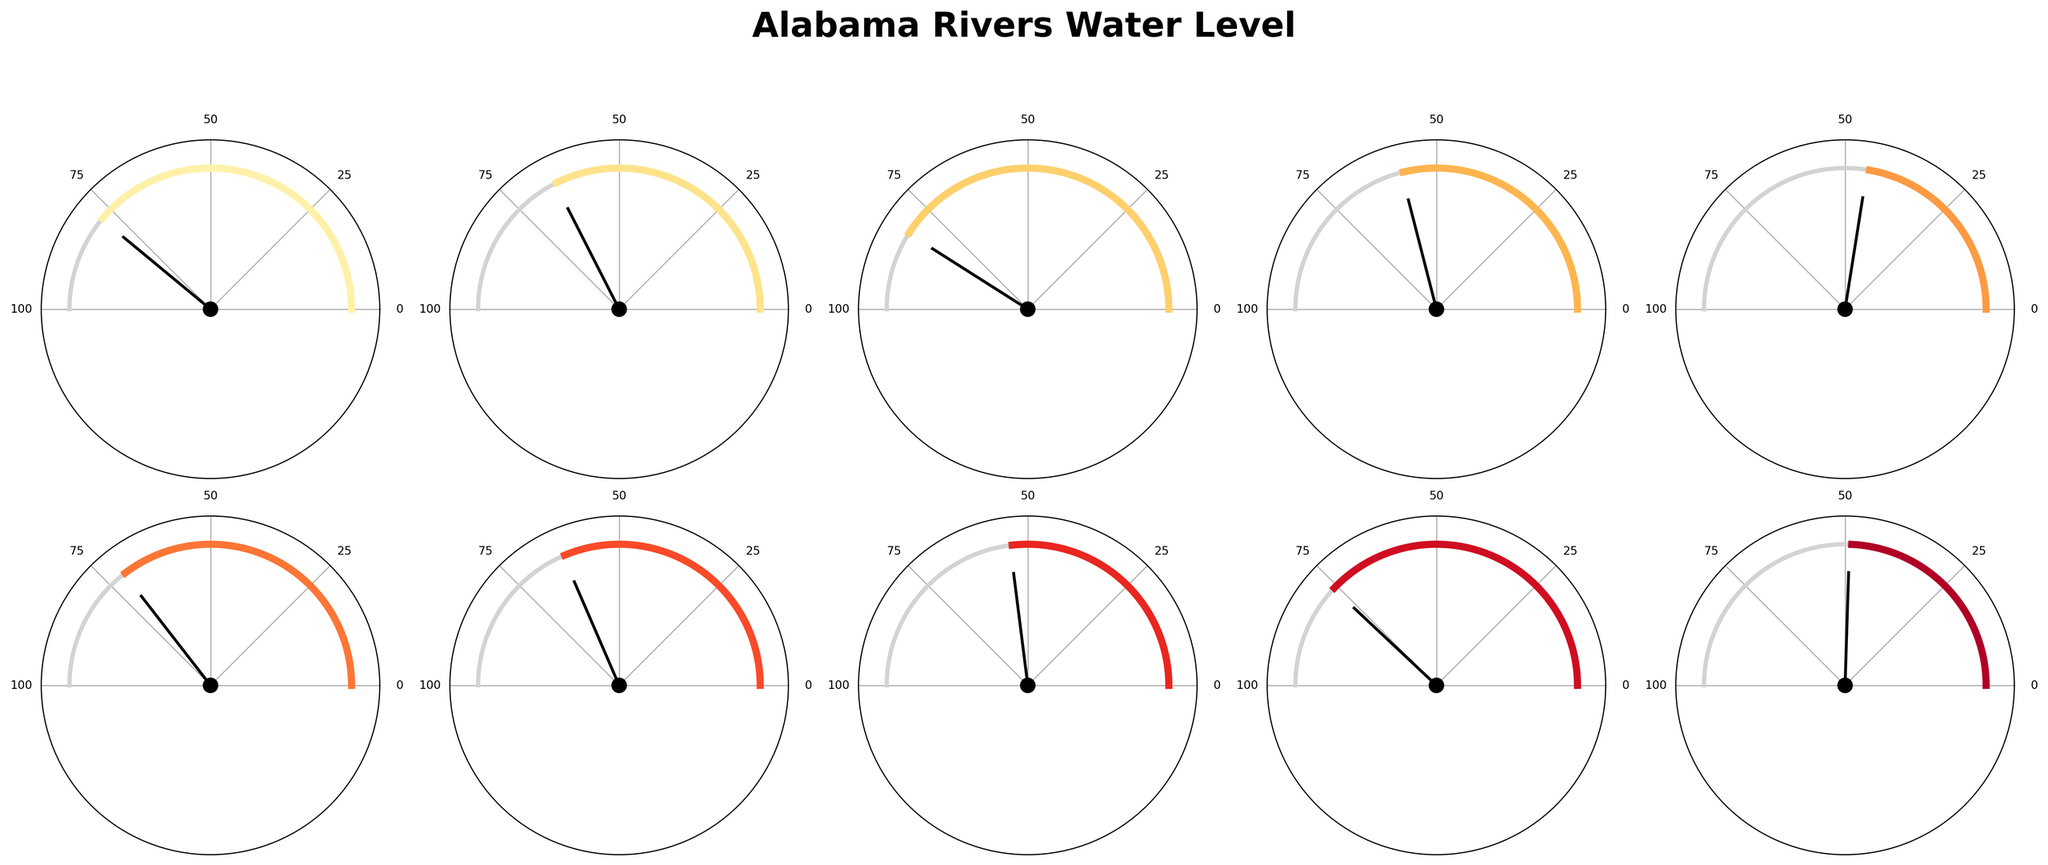What's the title of the figure? The title of the figure is displayed prominently at the top. It reads "Alabama Rivers Water Level."
Answer: Alabama Rivers Water Level How many rivers are displayed in the figure? The figure consists of two rows of plots, with five plots in each row, summing up to a total of 10 rivers.
Answer: 10 Which river has the highest water level percentage? By observing the gauge charts, we see that the "Alabama River" has the highest water level percentage at 82%.
Answer: Alabama River What is the range of water level percentages shown in the figure? The lowest percentage shown is 45% for Cahaba River, and the highest is 82% for Alabama River. Therefore, the range is from 45% to 82%.
Answer: 45% to 82% How does the water level of the Tallapoosa River compare to the Black Warrior River? The water level of the Tallapoosa River is 58%, whereas for the Black Warrior River it is 71%. The Black Warrior River has a higher water level.
Answer: Black Warrior River What is the average water level of all the rivers shown? Add all the water levels: 78 + 65 + 82 + 58 + 45 + 71 + 63 + 54 + 76 + 49 = 641. Then divide by the number of rivers (10): 641/10 = 64.1%.
Answer: 64.1% Which river has the second lowest water level percentage? The lowest water level percentage is Cahaba River at 45%, and the second lowest is Sipsey Fork at 49%.
Answer: Sipsey Fork Are there any rivers with the same water level percentage? By checking all the gauge charts, we see that none of the rivers share the exact same water level percentage.
Answer: No What's the median water level percentage of the rivers? Arrange the percentages in increasing order: 45, 49, 54, 58, 63, 65, 71, 76, 78, 82. As there are 10 values, the median is the average of the 5th and 6th values: (63 + 65)/2 = 64%.
Answer: 64% Which river's water level is closest to 75%? The water levels are: 78, 65, 82, 58, 45, 71, 63, 54, 76, 49. The Mobile River has a water level of 76%, which is the closest to 75%.
Answer: Mobile River 